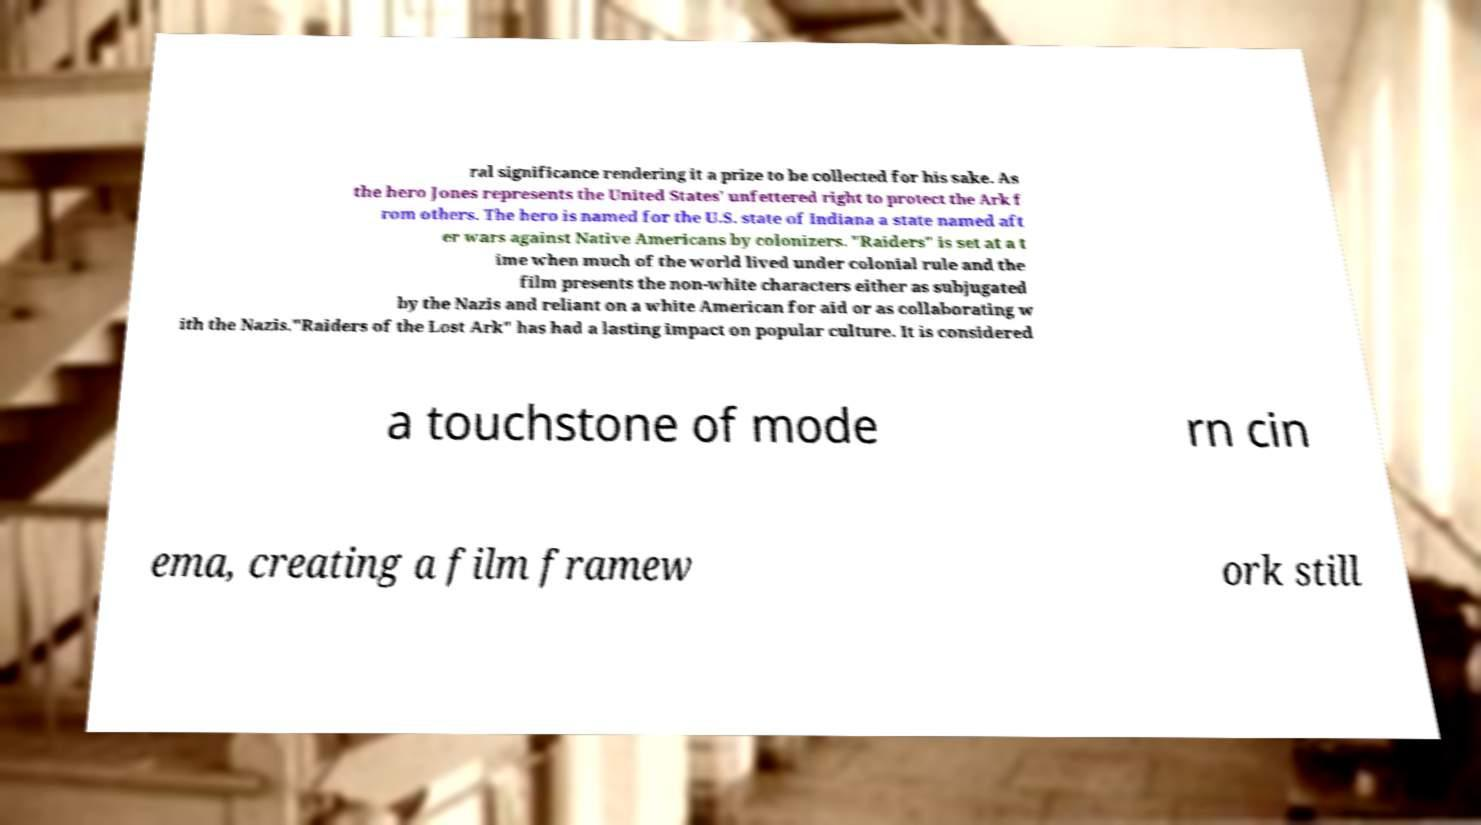Could you extract and type out the text from this image? ral significance rendering it a prize to be collected for his sake. As the hero Jones represents the United States' unfettered right to protect the Ark f rom others. The hero is named for the U.S. state of Indiana a state named aft er wars against Native Americans by colonizers. "Raiders" is set at a t ime when much of the world lived under colonial rule and the film presents the non-white characters either as subjugated by the Nazis and reliant on a white American for aid or as collaborating w ith the Nazis."Raiders of the Lost Ark" has had a lasting impact on popular culture. It is considered a touchstone of mode rn cin ema, creating a film framew ork still 